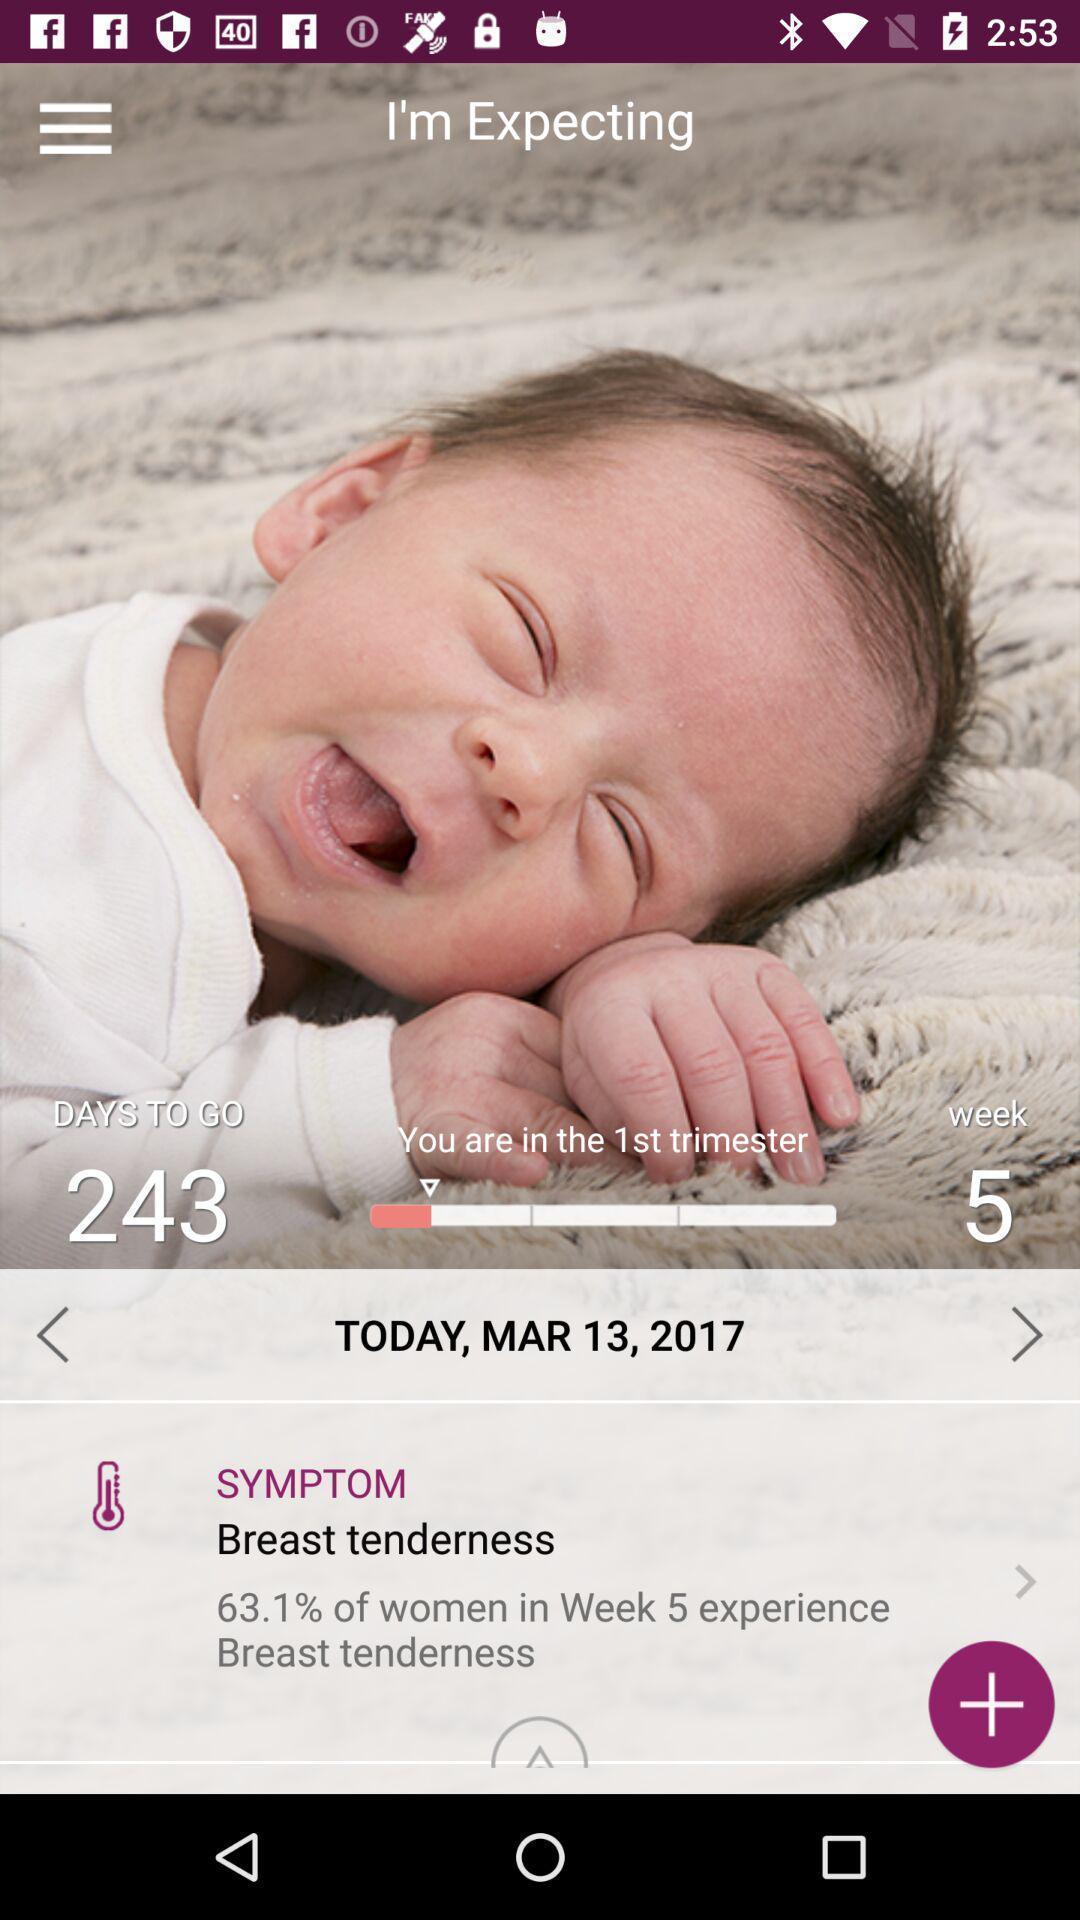Explain what's happening in this screen capture. Screen showing the baby due tracker on a health app. 